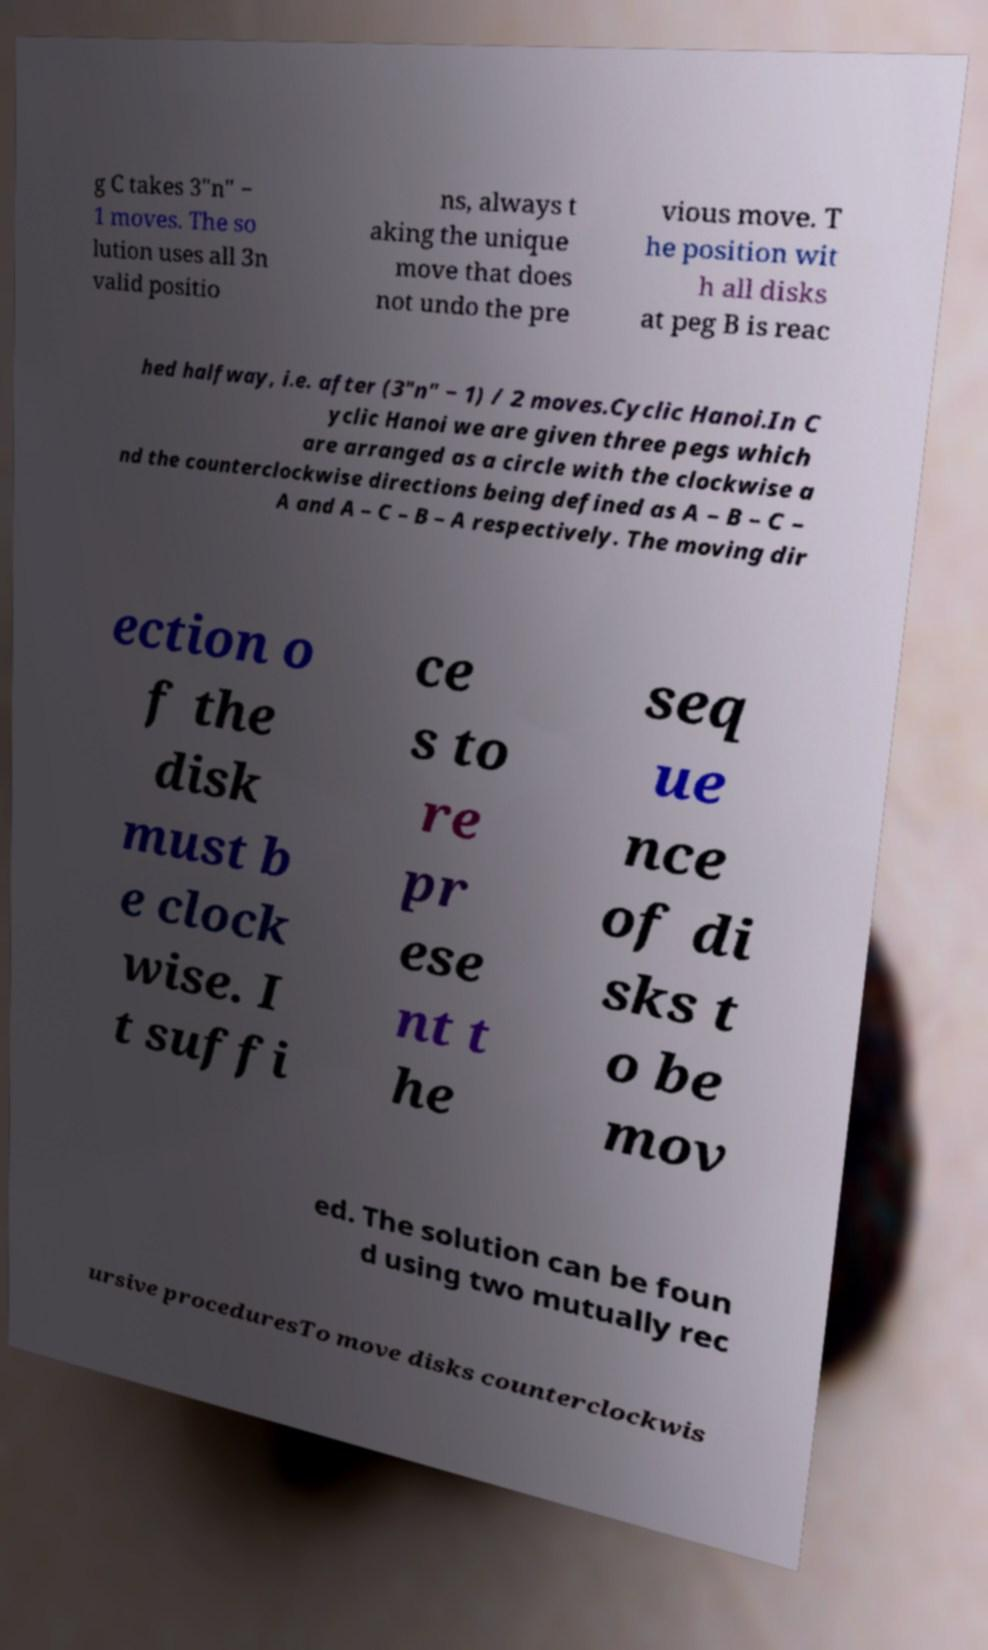I need the written content from this picture converted into text. Can you do that? g C takes 3"n" − 1 moves. The so lution uses all 3n valid positio ns, always t aking the unique move that does not undo the pre vious move. T he position wit h all disks at peg B is reac hed halfway, i.e. after (3"n" − 1) / 2 moves.Cyclic Hanoi.In C yclic Hanoi we are given three pegs which are arranged as a circle with the clockwise a nd the counterclockwise directions being defined as A – B – C – A and A – C – B – A respectively. The moving dir ection o f the disk must b e clock wise. I t suffi ce s to re pr ese nt t he seq ue nce of di sks t o be mov ed. The solution can be foun d using two mutually rec ursive proceduresTo move disks counterclockwis 